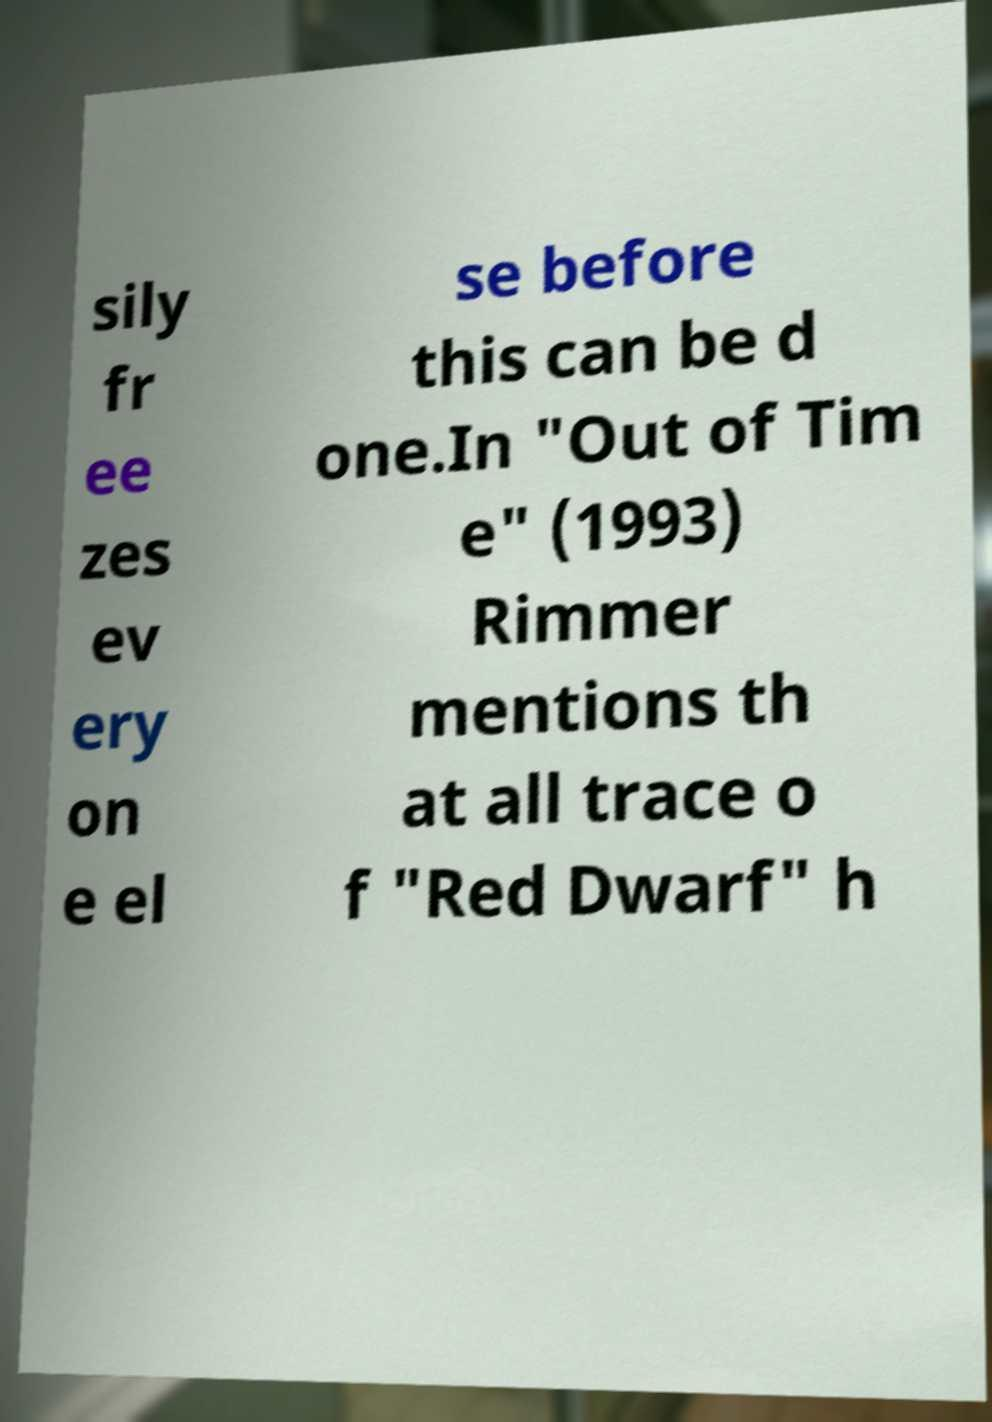Please identify and transcribe the text found in this image. sily fr ee zes ev ery on e el se before this can be d one.In "Out of Tim e" (1993) Rimmer mentions th at all trace o f "Red Dwarf" h 